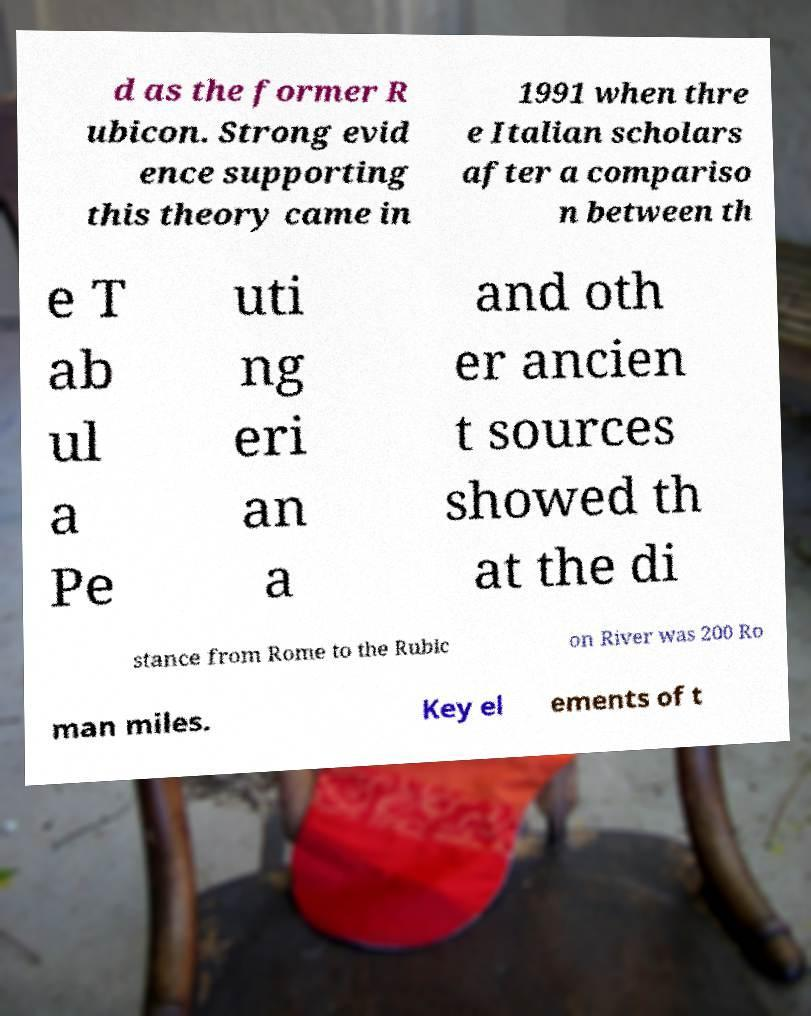I need the written content from this picture converted into text. Can you do that? d as the former R ubicon. Strong evid ence supporting this theory came in 1991 when thre e Italian scholars after a compariso n between th e T ab ul a Pe uti ng eri an a and oth er ancien t sources showed th at the di stance from Rome to the Rubic on River was 200 Ro man miles. Key el ements of t 